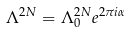<formula> <loc_0><loc_0><loc_500><loc_500>\Lambda ^ { 2 N } = \Lambda _ { 0 } ^ { 2 N } e ^ { 2 \pi i \alpha }</formula> 